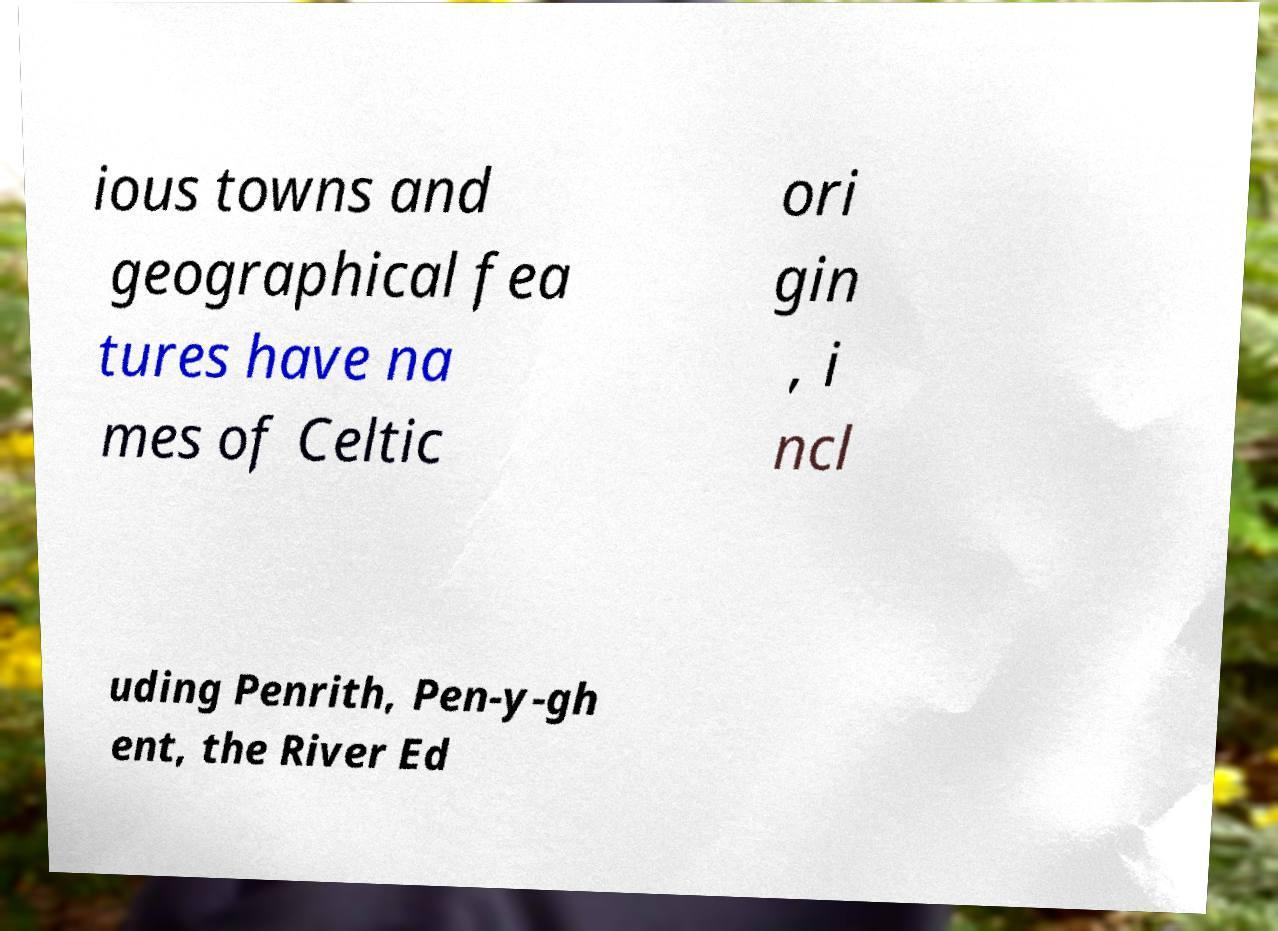I need the written content from this picture converted into text. Can you do that? ious towns and geographical fea tures have na mes of Celtic ori gin , i ncl uding Penrith, Pen-y-gh ent, the River Ed 